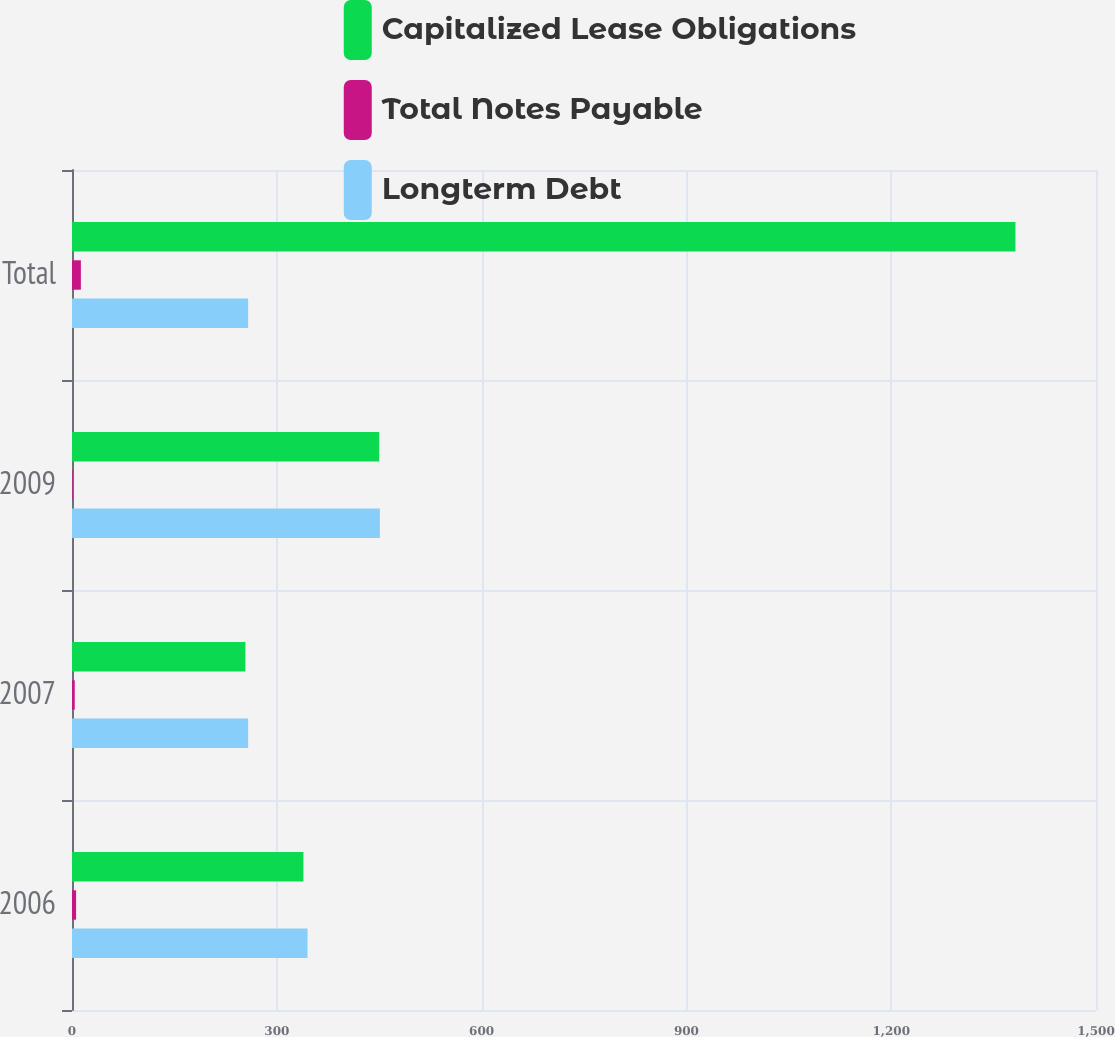Convert chart to OTSL. <chart><loc_0><loc_0><loc_500><loc_500><stacked_bar_chart><ecel><fcel>2006<fcel>2007<fcel>2009<fcel>Total<nl><fcel>Capitalized Lease Obligations<fcel>339<fcel>254<fcel>450<fcel>1382<nl><fcel>Total Notes Payable<fcel>6<fcel>4<fcel>1<fcel>13<nl><fcel>Longterm Debt<fcel>345<fcel>258<fcel>451<fcel>258<nl></chart> 